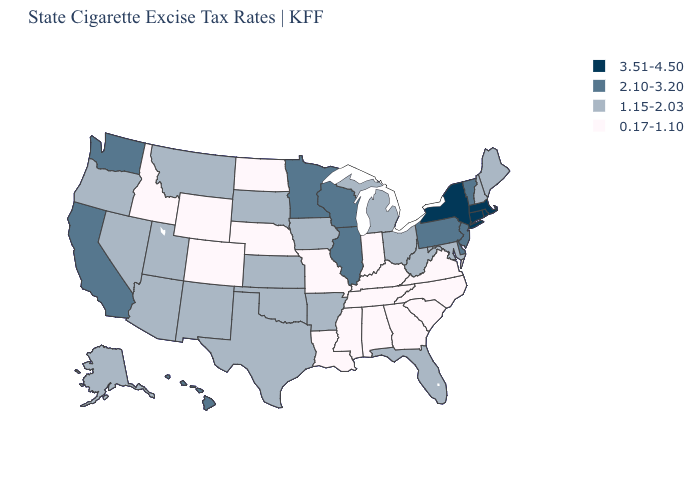What is the value of Oregon?
Quick response, please. 1.15-2.03. What is the value of Vermont?
Write a very short answer. 2.10-3.20. What is the value of Massachusetts?
Quick response, please. 3.51-4.50. Does Delaware have the same value as Pennsylvania?
Write a very short answer. Yes. Which states have the highest value in the USA?
Concise answer only. Connecticut, Massachusetts, New York, Rhode Island. Which states have the lowest value in the USA?
Give a very brief answer. Alabama, Colorado, Georgia, Idaho, Indiana, Kentucky, Louisiana, Mississippi, Missouri, Nebraska, North Carolina, North Dakota, South Carolina, Tennessee, Virginia, Wyoming. Is the legend a continuous bar?
Concise answer only. No. Does the map have missing data?
Write a very short answer. No. What is the value of Iowa?
Quick response, please. 1.15-2.03. Does Louisiana have the same value as North Carolina?
Write a very short answer. Yes. Name the states that have a value in the range 3.51-4.50?
Quick response, please. Connecticut, Massachusetts, New York, Rhode Island. Name the states that have a value in the range 2.10-3.20?
Keep it brief. California, Delaware, Hawaii, Illinois, Minnesota, New Jersey, Pennsylvania, Vermont, Washington, Wisconsin. Which states hav the highest value in the Northeast?
Keep it brief. Connecticut, Massachusetts, New York, Rhode Island. What is the value of Missouri?
Write a very short answer. 0.17-1.10. What is the value of Hawaii?
Keep it brief. 2.10-3.20. 